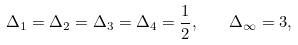<formula> <loc_0><loc_0><loc_500><loc_500>\Delta _ { 1 } = \Delta _ { 2 } = \Delta _ { 3 } = \Delta _ { 4 } = \frac { 1 } { 2 } , \quad \Delta _ { \infty } = 3 ,</formula> 